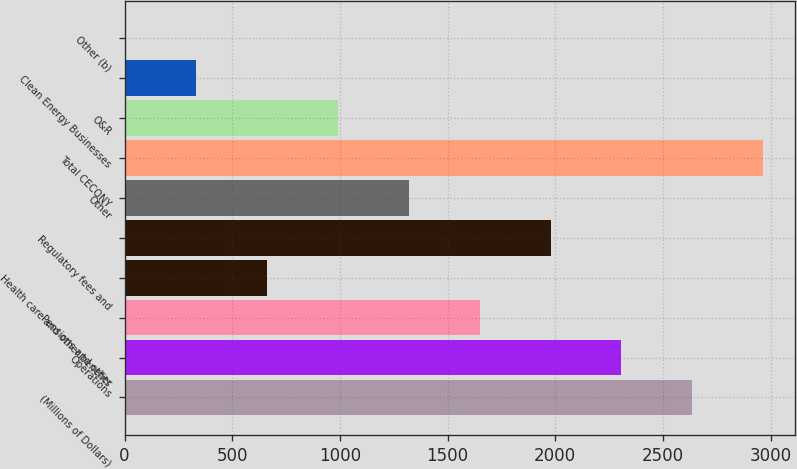Convert chart to OTSL. <chart><loc_0><loc_0><loc_500><loc_500><bar_chart><fcel>(Millions of Dollars)<fcel>Operations<fcel>Pensions and other<fcel>Health care and other benefits<fcel>Regulatory fees and<fcel>Other<fcel>Total CECONY<fcel>O&R<fcel>Clean Energy Businesses<fcel>Other (b)<nl><fcel>2636.2<fcel>2307.3<fcel>1649.5<fcel>662.8<fcel>1978.4<fcel>1320.6<fcel>2965.1<fcel>991.7<fcel>333.9<fcel>5<nl></chart> 